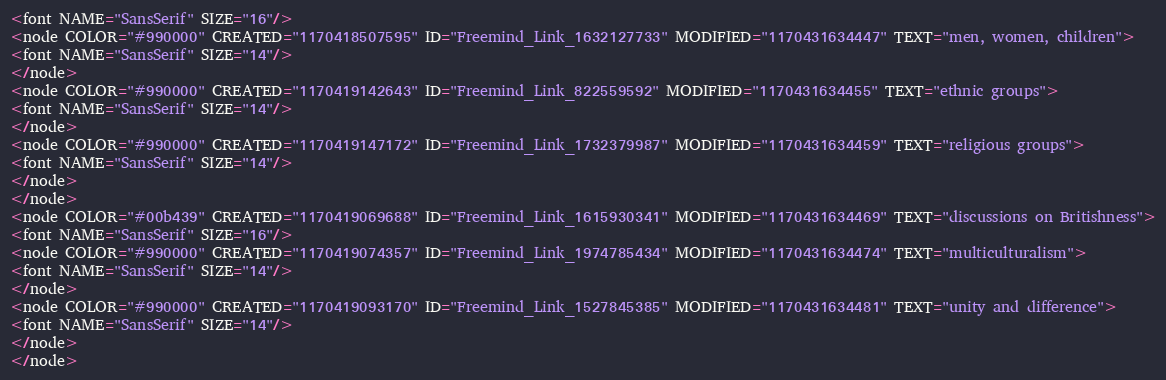Convert code to text. <code><loc_0><loc_0><loc_500><loc_500><_ObjectiveC_><font NAME="SansSerif" SIZE="16"/>
<node COLOR="#990000" CREATED="1170418507595" ID="Freemind_Link_1632127733" MODIFIED="1170431634447" TEXT="men, women, children">
<font NAME="SansSerif" SIZE="14"/>
</node>
<node COLOR="#990000" CREATED="1170419142643" ID="Freemind_Link_822559592" MODIFIED="1170431634455" TEXT="ethnic groups">
<font NAME="SansSerif" SIZE="14"/>
</node>
<node COLOR="#990000" CREATED="1170419147172" ID="Freemind_Link_1732379987" MODIFIED="1170431634459" TEXT="religious groups">
<font NAME="SansSerif" SIZE="14"/>
</node>
</node>
<node COLOR="#00b439" CREATED="1170419069688" ID="Freemind_Link_1615930341" MODIFIED="1170431634469" TEXT="discussions on Britishness">
<font NAME="SansSerif" SIZE="16"/>
<node COLOR="#990000" CREATED="1170419074357" ID="Freemind_Link_1974785434" MODIFIED="1170431634474" TEXT="multiculturalism">
<font NAME="SansSerif" SIZE="14"/>
</node>
<node COLOR="#990000" CREATED="1170419093170" ID="Freemind_Link_1527845385" MODIFIED="1170431634481" TEXT="unity and difference">
<font NAME="SansSerif" SIZE="14"/>
</node>
</node></code> 